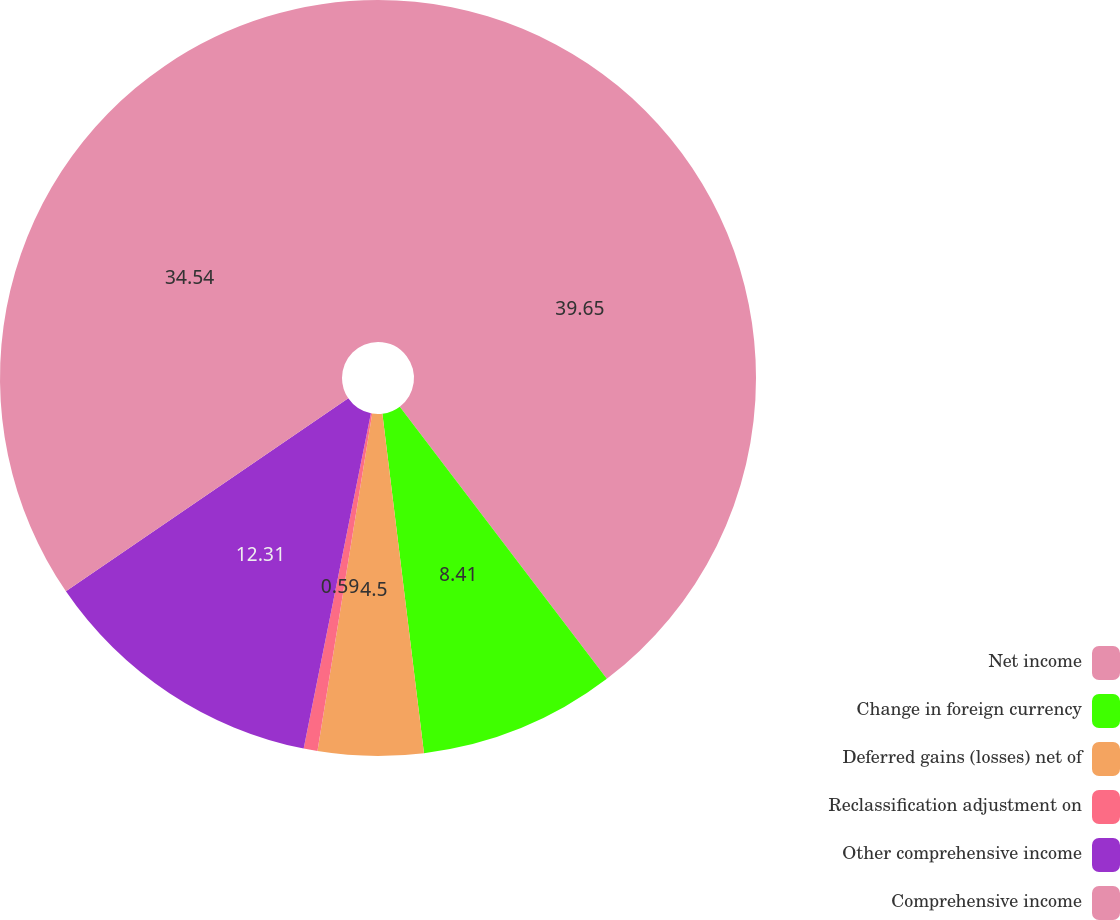Convert chart to OTSL. <chart><loc_0><loc_0><loc_500><loc_500><pie_chart><fcel>Net income<fcel>Change in foreign currency<fcel>Deferred gains (losses) net of<fcel>Reclassification adjustment on<fcel>Other comprehensive income<fcel>Comprehensive income<nl><fcel>39.65%<fcel>8.41%<fcel>4.5%<fcel>0.59%<fcel>12.31%<fcel>34.54%<nl></chart> 